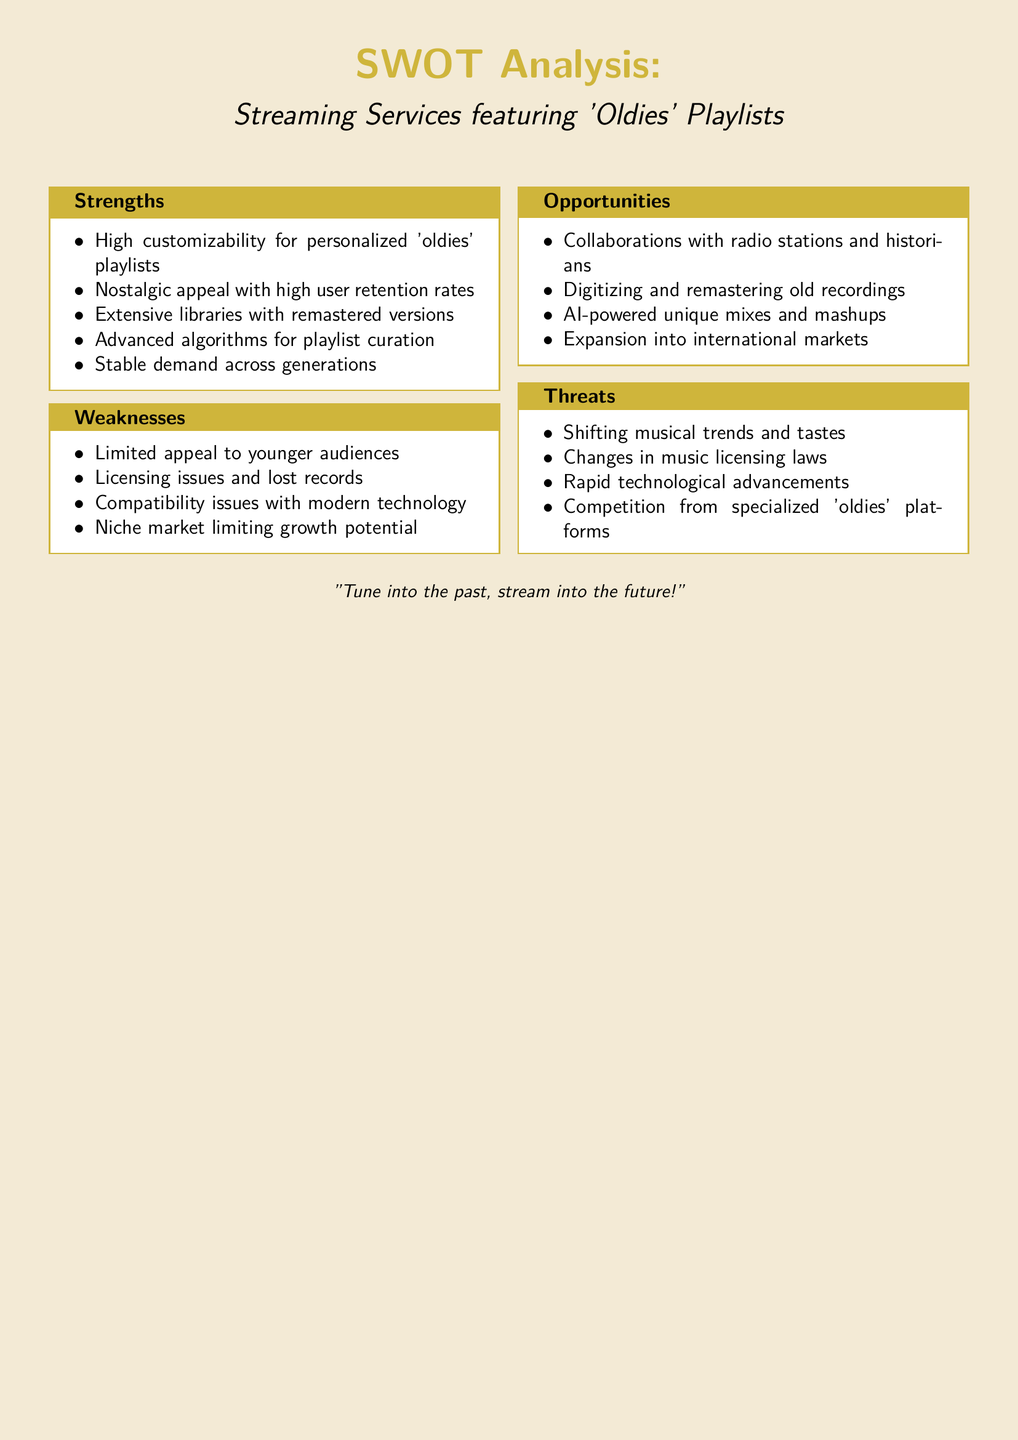What are the strengths of streaming services featuring 'oldies' playlists? The strengths are outlined in the 'Strengths' section of the SWOT analysis, which lists factors such as customizability, nostalgic appeal, and extensive libraries.
Answer: High customizability for personalized 'oldies' playlists, Nostalgic appeal with high user retention rates, Extensive libraries with remastered versions, Advanced algorithms for playlist curation, Stable demand across generations What is listed as a weakness related to technology? The weaknesses section contains points about various limitations, and compatibility issues are specifically mentioned as a technology concern.
Answer: Compatibility issues with modern technology What opportunities are mentioned for streaming services? The 'Opportunities' section details potential growth avenues for streaming services, such as collaborations and digitization.
Answer: Collaborations with radio stations and historians, Digitizing and remastering old recordings, AI-powered unique mixes and mashups, Expansion into international markets What is the primary threat from competitors? The 'Threats' section highlights competition from platforms focused exclusively on 'oldies,' emphasizing they pose a risk to streaming services.
Answer: Competition from specialized 'oldies' platforms How many points are listed under weaknesses? The weaknesses section includes a specific number of items reflecting challenges faced by streaming services.
Answer: Four 